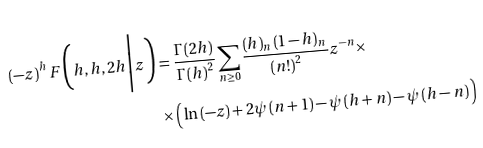<formula> <loc_0><loc_0><loc_500><loc_500>\left ( - z \right ) ^ { h } F \Big ( h , h , 2 h \Big | z \Big ) & = \frac { \Gamma \left ( 2 h \right ) } { \Gamma \left ( h \right ) ^ { 2 } } \sum _ { n \geq 0 } \frac { \left ( h \right ) _ { n } \left ( 1 - h \right ) _ { n } } { \left ( n ! \right ) ^ { 2 } } z ^ { - n } \times \\ & \times \Big ( \ln \left ( - z \right ) + 2 \psi \left ( n + 1 \right ) - \psi \left ( h + n \right ) - \psi \left ( h - n \right ) \Big )</formula> 